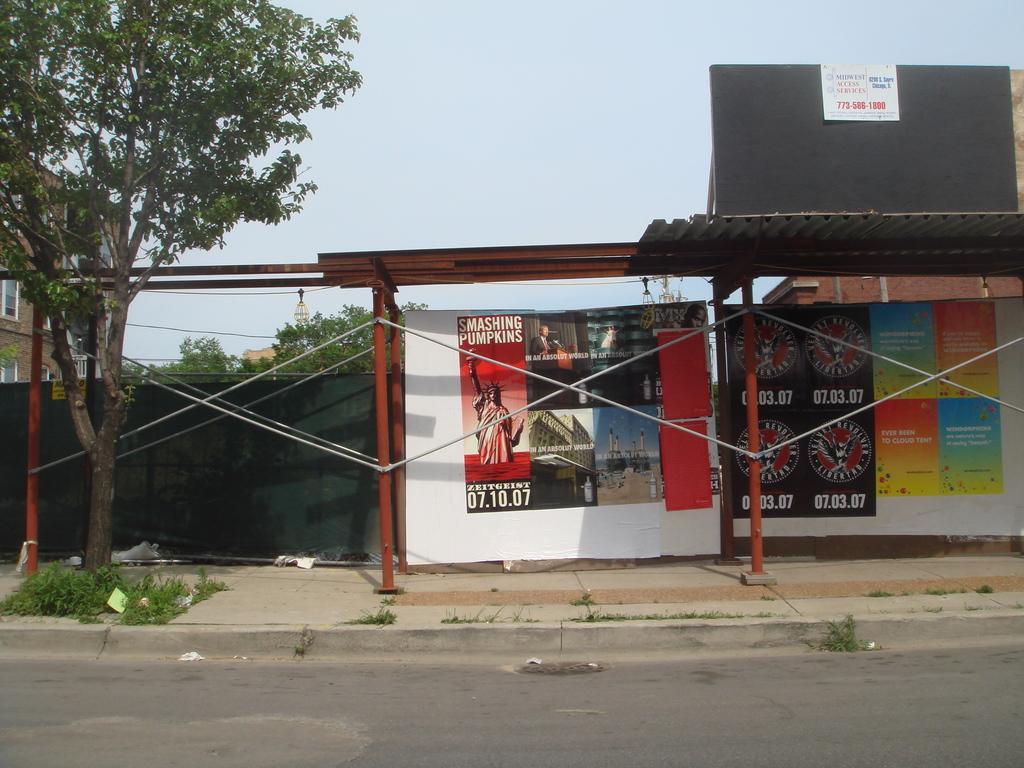Can you describe this image briefly? Under this open shed there are hoardings. Left side of the image there are trees and building with windows. 